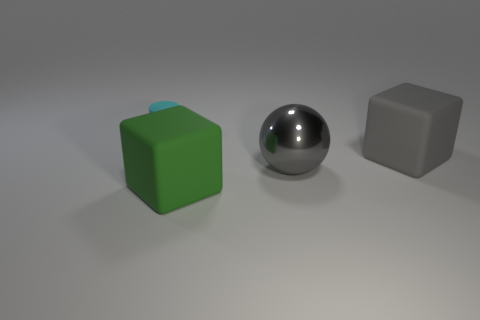Add 2 tiny cyan metallic objects. How many objects exist? 6 Subtract all balls. How many objects are left? 3 Subtract 1 gray balls. How many objects are left? 3 Subtract all big blue matte cylinders. Subtract all gray metallic balls. How many objects are left? 3 Add 3 large objects. How many large objects are left? 6 Add 3 gray spheres. How many gray spheres exist? 4 